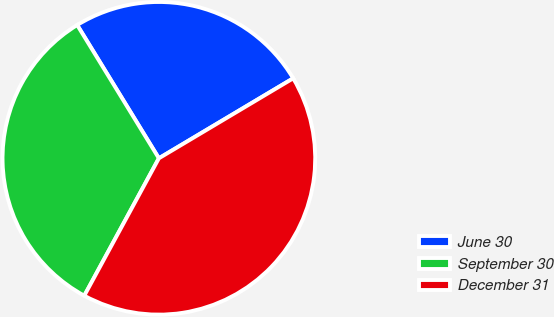Convert chart to OTSL. <chart><loc_0><loc_0><loc_500><loc_500><pie_chart><fcel>June 30<fcel>September 30<fcel>December 31<nl><fcel>25.2%<fcel>33.33%<fcel>41.46%<nl></chart> 